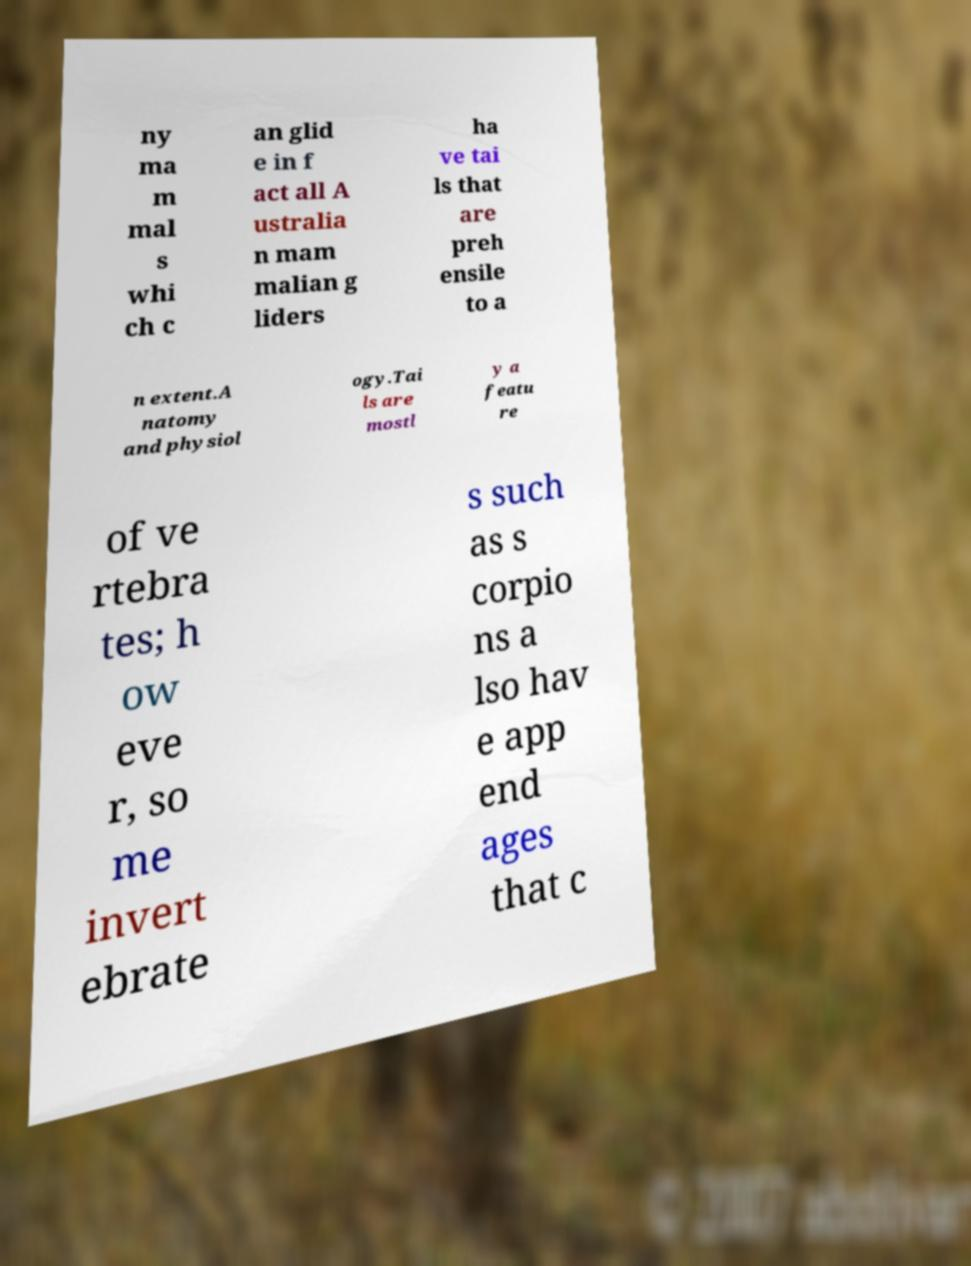Could you extract and type out the text from this image? ny ma m mal s whi ch c an glid e in f act all A ustralia n mam malian g liders ha ve tai ls that are preh ensile to a n extent.A natomy and physiol ogy.Tai ls are mostl y a featu re of ve rtebra tes; h ow eve r, so me invert ebrate s such as s corpio ns a lso hav e app end ages that c 